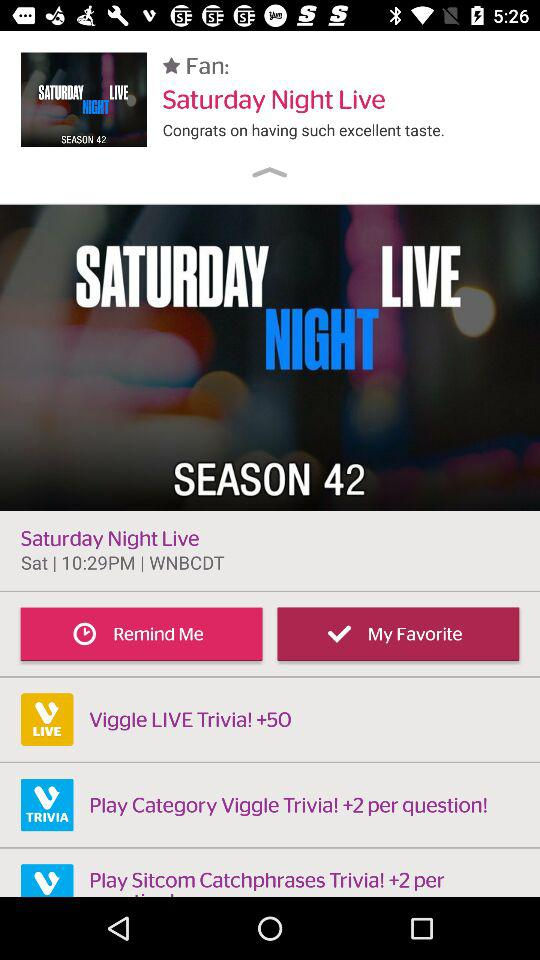What is the show name? The name of the show is "Saturday Night Live". 